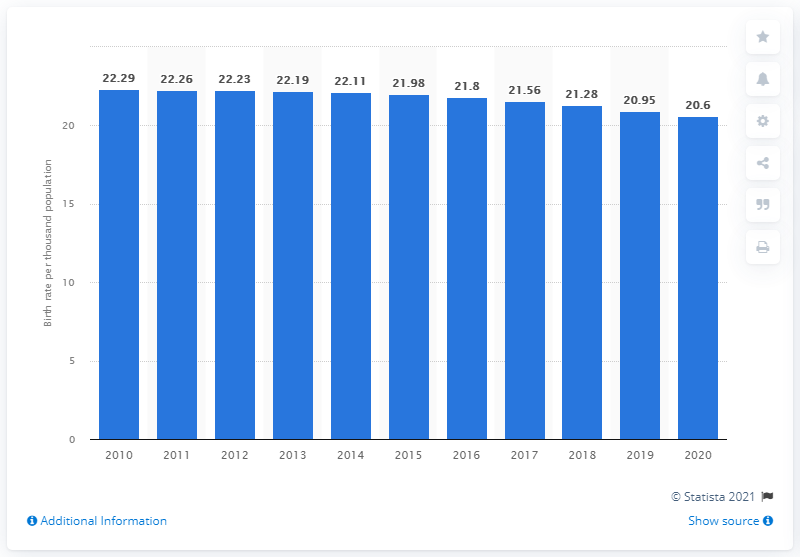Give some essential details in this illustration. The crude birth rate in Fiji in 2020 was 20.6. 